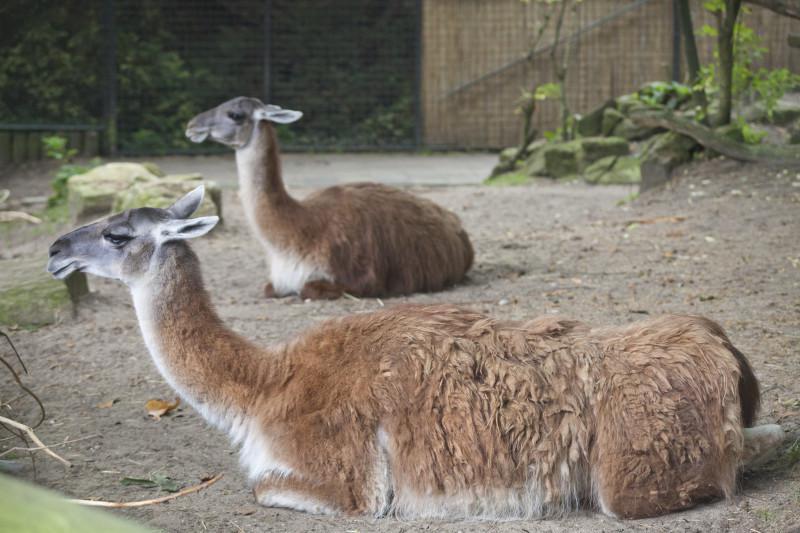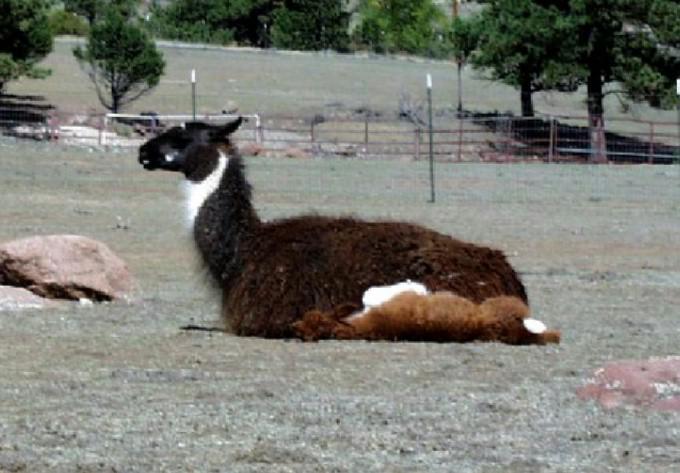The first image is the image on the left, the second image is the image on the right. Assess this claim about the two images: "One image includes a forward-facing standing llama, and the other image includes a reclining llama with another llama alongside it.". Correct or not? Answer yes or no. No. The first image is the image on the left, the second image is the image on the right. Evaluate the accuracy of this statement regarding the images: "One image shows two alpacas sitting next to each other.". Is it true? Answer yes or no. Yes. 